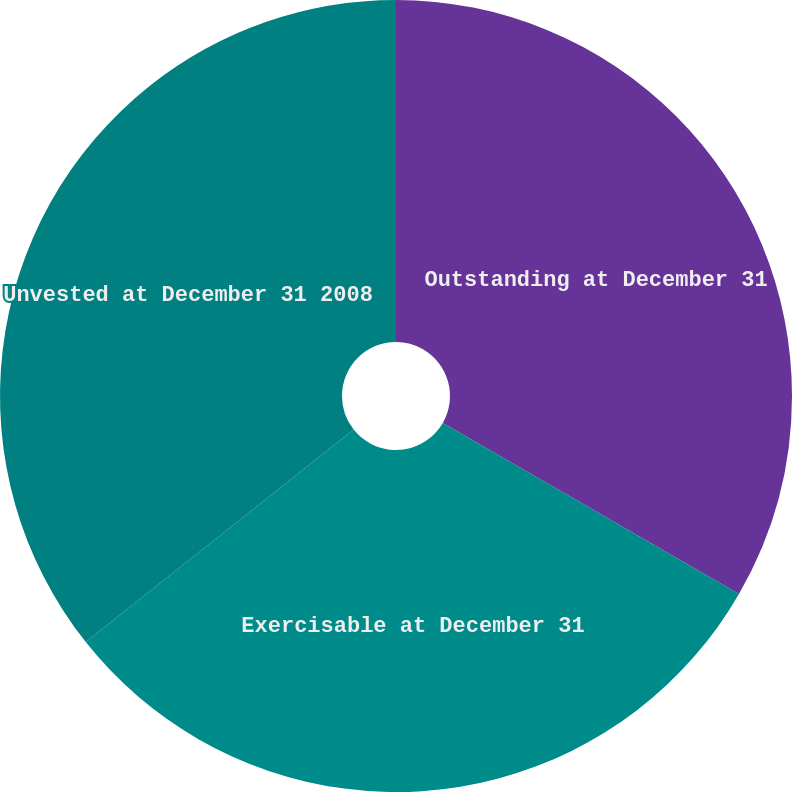Convert chart to OTSL. <chart><loc_0><loc_0><loc_500><loc_500><pie_chart><fcel>Outstanding at December 31<fcel>Exercisable at December 31<fcel>Unvested at December 31 2008<nl><fcel>33.33%<fcel>30.99%<fcel>35.67%<nl></chart> 